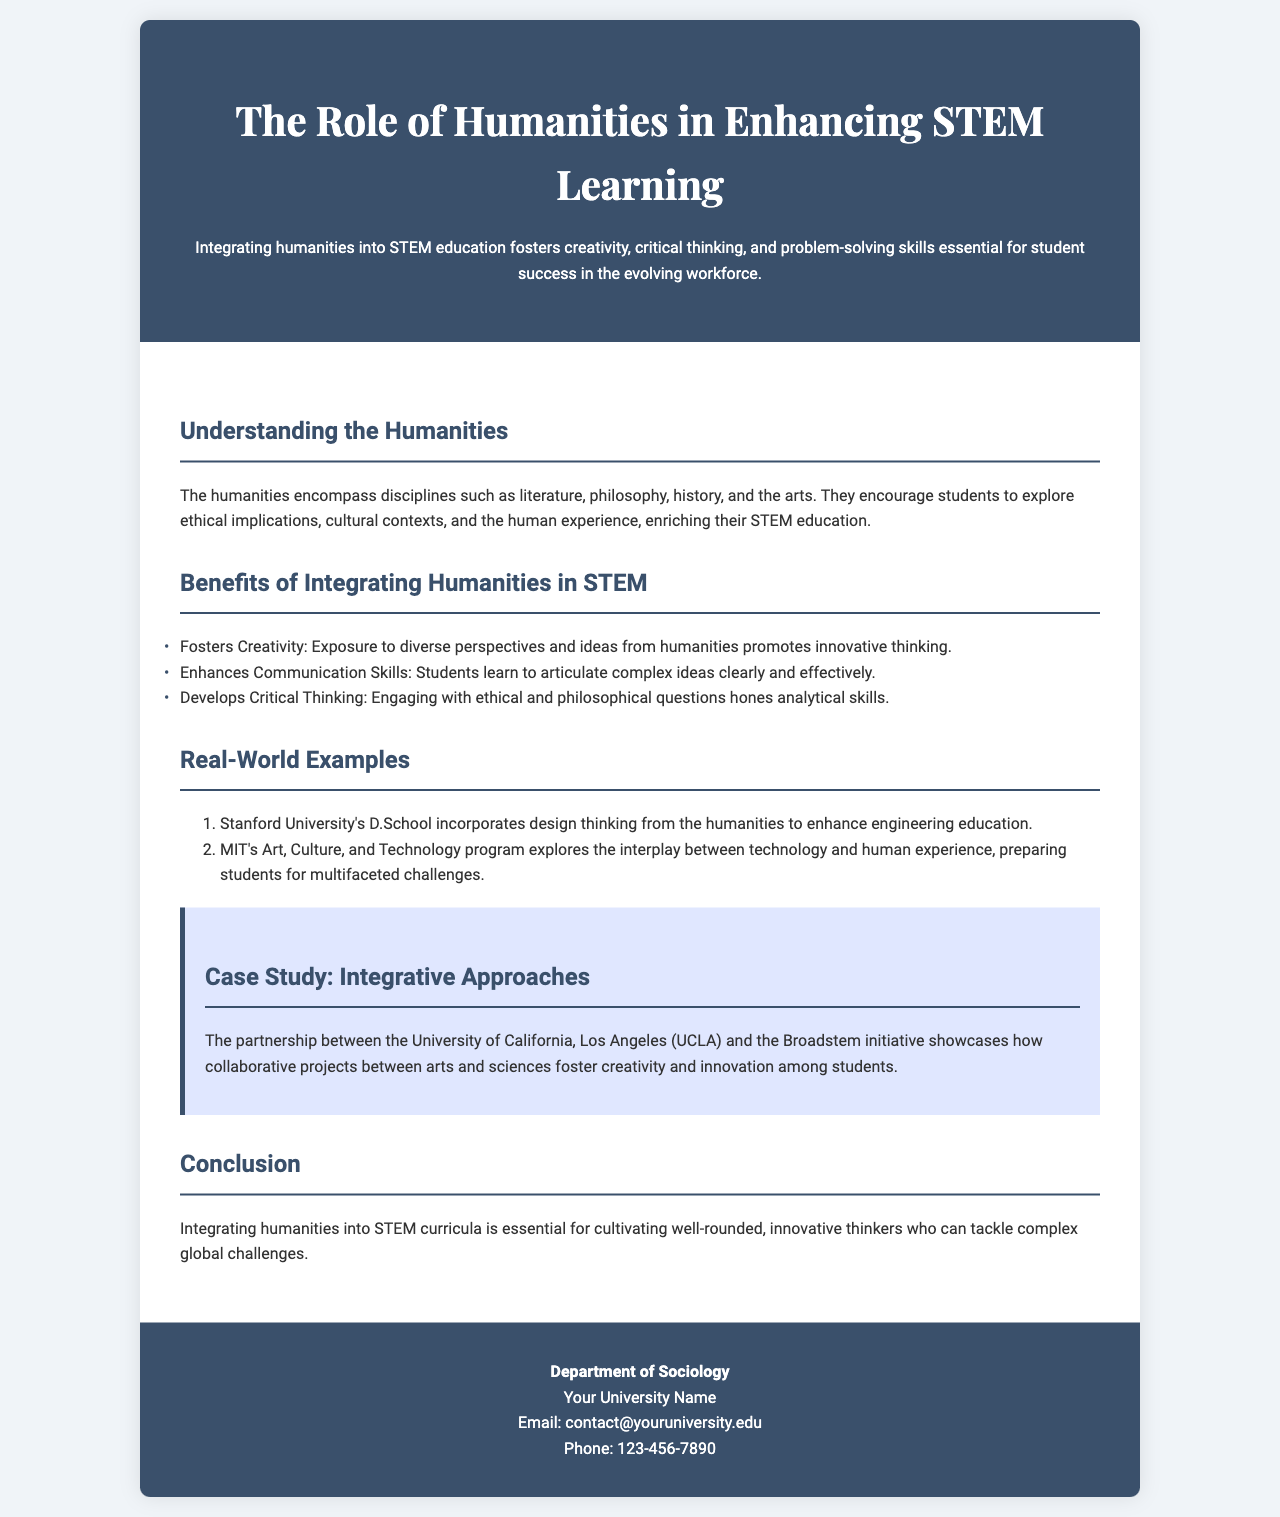What is the title of the brochure? The title is prominently displayed at the top of the document, introducing the main topic.
Answer: The Role of Humanities in Enhancing STEM Learning Which disciplines are included in the humanities? The document specifies the various disciplines that make up the humanities, which enrich STEM education.
Answer: Literature, philosophy, history, and the arts What is one benefit of integrating humanities in STEM? The document lists several benefits, highlighting a key advantage of this integration.
Answer: Fosters Creativity What university is mentioned with a program that incorporates design thinking? The document provides a specific institution that applies a multidisciplinary approach to enhance engineering.
Answer: Stanford University What is the name of the case study mentioned? The case study highlights collaborative projects between arts and sciences in the document.
Answer: Integrative Approaches How many real-world examples are provided? The document enumerates the number of examples to illustrate the successful integration of humanities in STEM.
Answer: Two What is a key conclusion drawn in the brochure? The document sums up its main point regarding the importance of integrating humanities in STEM education.
Answer: Essential for cultivating well-rounded, innovative thinkers What is the email address provided for contact? The contact information section includes a specific email for inquiries related to the document's topic.
Answer: contact@youruniversity.edu What program is mentioned in connection with MIT? The document references a program that reflects the intersection of technology and humanities.
Answer: Art, Culture, and Technology program 